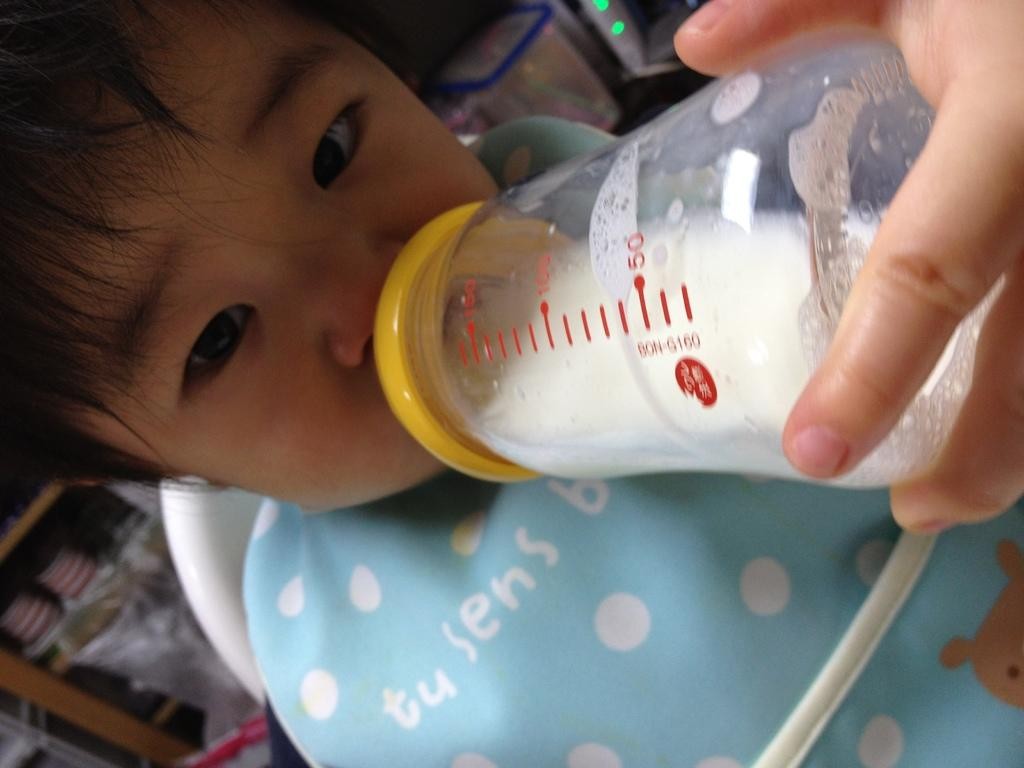What is the main subject of the image? There is a baby in the image. What is the baby doing in the image? The baby is drinking milk. Whose hand is holding the milk bottle in the image? There is a human hand holding a milk bottle in the image. What can be seen in the background of the image? There is a light and a cupboard in the background of the image. What type of sweater is the baby wearing in the image? The image does not show the baby wearing a sweater, so it cannot be determined from the image. How many thumbs can be seen holding the milk bottle in the image? The image only shows one hand holding the milk bottle, and it is not possible to determine the number of thumbs from the image. 